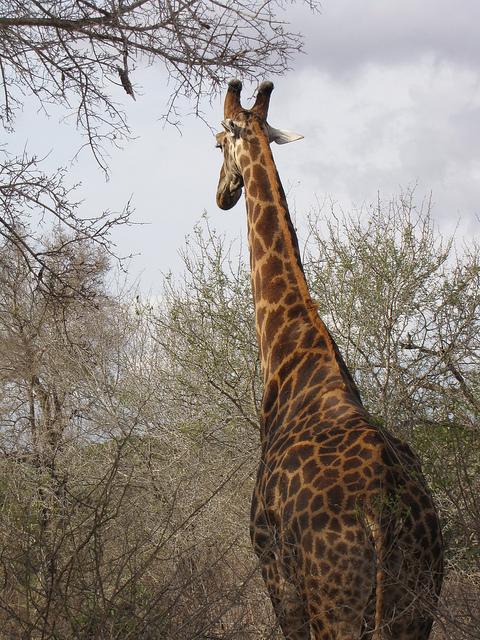How many people in this photo?
Give a very brief answer. 0. How many giraffes are there?
Give a very brief answer. 1. How many skateboard wheels can you see?
Give a very brief answer. 0. 